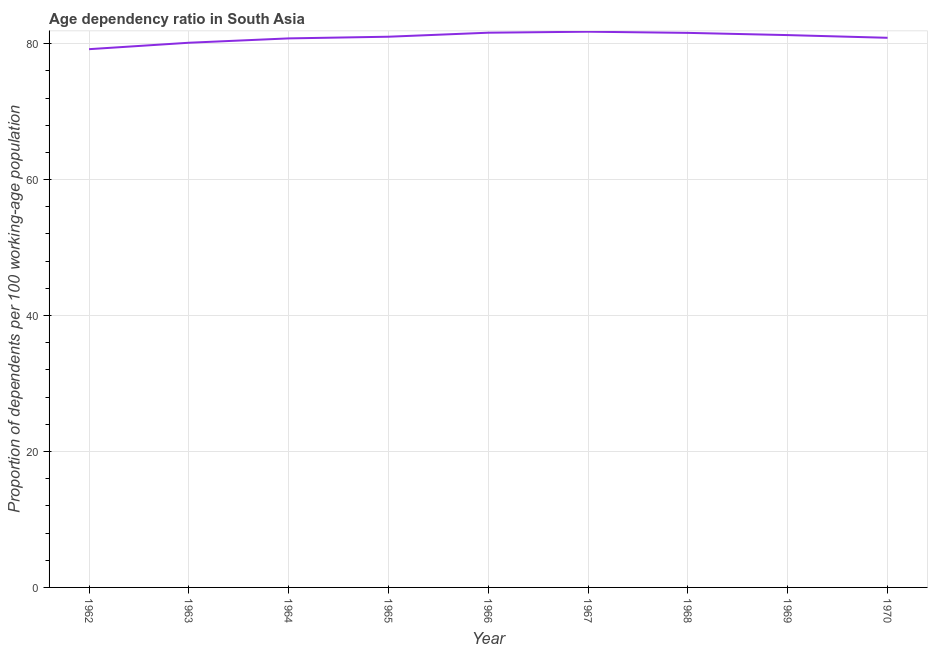What is the age dependency ratio in 1965?
Your response must be concise. 81.02. Across all years, what is the maximum age dependency ratio?
Make the answer very short. 81.76. Across all years, what is the minimum age dependency ratio?
Offer a very short reply. 79.19. In which year was the age dependency ratio maximum?
Offer a very short reply. 1967. What is the sum of the age dependency ratio?
Keep it short and to the point. 728.2. What is the difference between the age dependency ratio in 1966 and 1968?
Your answer should be very brief. 0.03. What is the average age dependency ratio per year?
Ensure brevity in your answer.  80.91. What is the median age dependency ratio?
Your answer should be compact. 81.02. What is the ratio of the age dependency ratio in 1963 to that in 1970?
Provide a succinct answer. 0.99. What is the difference between the highest and the second highest age dependency ratio?
Offer a terse response. 0.15. What is the difference between the highest and the lowest age dependency ratio?
Your answer should be very brief. 2.57. In how many years, is the age dependency ratio greater than the average age dependency ratio taken over all years?
Offer a terse response. 5. How many years are there in the graph?
Your answer should be very brief. 9. What is the difference between two consecutive major ticks on the Y-axis?
Your answer should be compact. 20. Does the graph contain any zero values?
Your response must be concise. No. What is the title of the graph?
Offer a terse response. Age dependency ratio in South Asia. What is the label or title of the X-axis?
Provide a short and direct response. Year. What is the label or title of the Y-axis?
Your answer should be very brief. Proportion of dependents per 100 working-age population. What is the Proportion of dependents per 100 working-age population in 1962?
Give a very brief answer. 79.19. What is the Proportion of dependents per 100 working-age population in 1963?
Offer a terse response. 80.13. What is the Proportion of dependents per 100 working-age population of 1964?
Provide a succinct answer. 80.78. What is the Proportion of dependents per 100 working-age population in 1965?
Your answer should be very brief. 81.02. What is the Proportion of dependents per 100 working-age population of 1966?
Your answer should be very brief. 81.61. What is the Proportion of dependents per 100 working-age population of 1967?
Give a very brief answer. 81.76. What is the Proportion of dependents per 100 working-age population in 1968?
Provide a short and direct response. 81.59. What is the Proportion of dependents per 100 working-age population in 1969?
Provide a succinct answer. 81.26. What is the Proportion of dependents per 100 working-age population of 1970?
Your response must be concise. 80.86. What is the difference between the Proportion of dependents per 100 working-age population in 1962 and 1963?
Offer a very short reply. -0.95. What is the difference between the Proportion of dependents per 100 working-age population in 1962 and 1964?
Provide a succinct answer. -1.59. What is the difference between the Proportion of dependents per 100 working-age population in 1962 and 1965?
Your answer should be very brief. -1.83. What is the difference between the Proportion of dependents per 100 working-age population in 1962 and 1966?
Provide a short and direct response. -2.42. What is the difference between the Proportion of dependents per 100 working-age population in 1962 and 1967?
Your answer should be very brief. -2.57. What is the difference between the Proportion of dependents per 100 working-age population in 1962 and 1968?
Keep it short and to the point. -2.4. What is the difference between the Proportion of dependents per 100 working-age population in 1962 and 1969?
Keep it short and to the point. -2.07. What is the difference between the Proportion of dependents per 100 working-age population in 1962 and 1970?
Provide a succinct answer. -1.67. What is the difference between the Proportion of dependents per 100 working-age population in 1963 and 1964?
Ensure brevity in your answer.  -0.64. What is the difference between the Proportion of dependents per 100 working-age population in 1963 and 1965?
Keep it short and to the point. -0.89. What is the difference between the Proportion of dependents per 100 working-age population in 1963 and 1966?
Make the answer very short. -1.48. What is the difference between the Proportion of dependents per 100 working-age population in 1963 and 1967?
Your response must be concise. -1.62. What is the difference between the Proportion of dependents per 100 working-age population in 1963 and 1968?
Your response must be concise. -1.45. What is the difference between the Proportion of dependents per 100 working-age population in 1963 and 1969?
Provide a short and direct response. -1.12. What is the difference between the Proportion of dependents per 100 working-age population in 1963 and 1970?
Your answer should be very brief. -0.73. What is the difference between the Proportion of dependents per 100 working-age population in 1964 and 1965?
Give a very brief answer. -0.24. What is the difference between the Proportion of dependents per 100 working-age population in 1964 and 1966?
Offer a terse response. -0.84. What is the difference between the Proportion of dependents per 100 working-age population in 1964 and 1967?
Make the answer very short. -0.98. What is the difference between the Proportion of dependents per 100 working-age population in 1964 and 1968?
Your answer should be compact. -0.81. What is the difference between the Proportion of dependents per 100 working-age population in 1964 and 1969?
Offer a very short reply. -0.48. What is the difference between the Proportion of dependents per 100 working-age population in 1964 and 1970?
Provide a short and direct response. -0.09. What is the difference between the Proportion of dependents per 100 working-age population in 1965 and 1966?
Give a very brief answer. -0.59. What is the difference between the Proportion of dependents per 100 working-age population in 1965 and 1967?
Provide a succinct answer. -0.74. What is the difference between the Proportion of dependents per 100 working-age population in 1965 and 1968?
Make the answer very short. -0.57. What is the difference between the Proportion of dependents per 100 working-age population in 1965 and 1969?
Your answer should be very brief. -0.24. What is the difference between the Proportion of dependents per 100 working-age population in 1965 and 1970?
Your answer should be very brief. 0.16. What is the difference between the Proportion of dependents per 100 working-age population in 1966 and 1967?
Your answer should be compact. -0.15. What is the difference between the Proportion of dependents per 100 working-age population in 1966 and 1968?
Provide a succinct answer. 0.03. What is the difference between the Proportion of dependents per 100 working-age population in 1966 and 1969?
Provide a short and direct response. 0.35. What is the difference between the Proportion of dependents per 100 working-age population in 1966 and 1970?
Offer a very short reply. 0.75. What is the difference between the Proportion of dependents per 100 working-age population in 1967 and 1968?
Offer a very short reply. 0.17. What is the difference between the Proportion of dependents per 100 working-age population in 1967 and 1969?
Your answer should be very brief. 0.5. What is the difference between the Proportion of dependents per 100 working-age population in 1967 and 1970?
Offer a terse response. 0.9. What is the difference between the Proportion of dependents per 100 working-age population in 1968 and 1969?
Your answer should be very brief. 0.33. What is the difference between the Proportion of dependents per 100 working-age population in 1968 and 1970?
Your answer should be very brief. 0.72. What is the difference between the Proportion of dependents per 100 working-age population in 1969 and 1970?
Provide a short and direct response. 0.4. What is the ratio of the Proportion of dependents per 100 working-age population in 1962 to that in 1966?
Your answer should be very brief. 0.97. What is the ratio of the Proportion of dependents per 100 working-age population in 1962 to that in 1968?
Ensure brevity in your answer.  0.97. What is the ratio of the Proportion of dependents per 100 working-age population in 1962 to that in 1969?
Keep it short and to the point. 0.97. What is the ratio of the Proportion of dependents per 100 working-age population in 1962 to that in 1970?
Provide a succinct answer. 0.98. What is the ratio of the Proportion of dependents per 100 working-age population in 1963 to that in 1965?
Offer a very short reply. 0.99. What is the ratio of the Proportion of dependents per 100 working-age population in 1963 to that in 1967?
Your answer should be very brief. 0.98. What is the ratio of the Proportion of dependents per 100 working-age population in 1963 to that in 1969?
Your response must be concise. 0.99. What is the ratio of the Proportion of dependents per 100 working-age population in 1964 to that in 1967?
Provide a short and direct response. 0.99. What is the ratio of the Proportion of dependents per 100 working-age population in 1965 to that in 1967?
Offer a very short reply. 0.99. What is the ratio of the Proportion of dependents per 100 working-age population in 1966 to that in 1967?
Your answer should be very brief. 1. What is the ratio of the Proportion of dependents per 100 working-age population in 1966 to that in 1969?
Your response must be concise. 1. What is the ratio of the Proportion of dependents per 100 working-age population in 1967 to that in 1970?
Offer a very short reply. 1.01. What is the ratio of the Proportion of dependents per 100 working-age population in 1969 to that in 1970?
Your answer should be very brief. 1. 